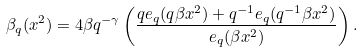<formula> <loc_0><loc_0><loc_500><loc_500>\beta _ { q } ( x ^ { 2 } ) = 4 \beta q ^ { - \gamma } \left ( \frac { q e _ { q } ( q \beta x ^ { 2 } ) + q ^ { - 1 } e _ { q } ( q ^ { - 1 } \beta x ^ { 2 } ) } { e _ { q } ( \beta x ^ { 2 } ) } \right ) .</formula> 